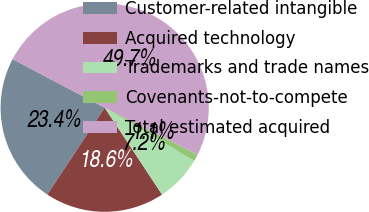<chart> <loc_0><loc_0><loc_500><loc_500><pie_chart><fcel>Customer-related intangible<fcel>Acquired technology<fcel>Trademarks and trade names<fcel>Covenants-not-to-compete<fcel>Total estimated acquired<nl><fcel>23.44%<fcel>18.57%<fcel>7.2%<fcel>1.07%<fcel>49.73%<nl></chart> 